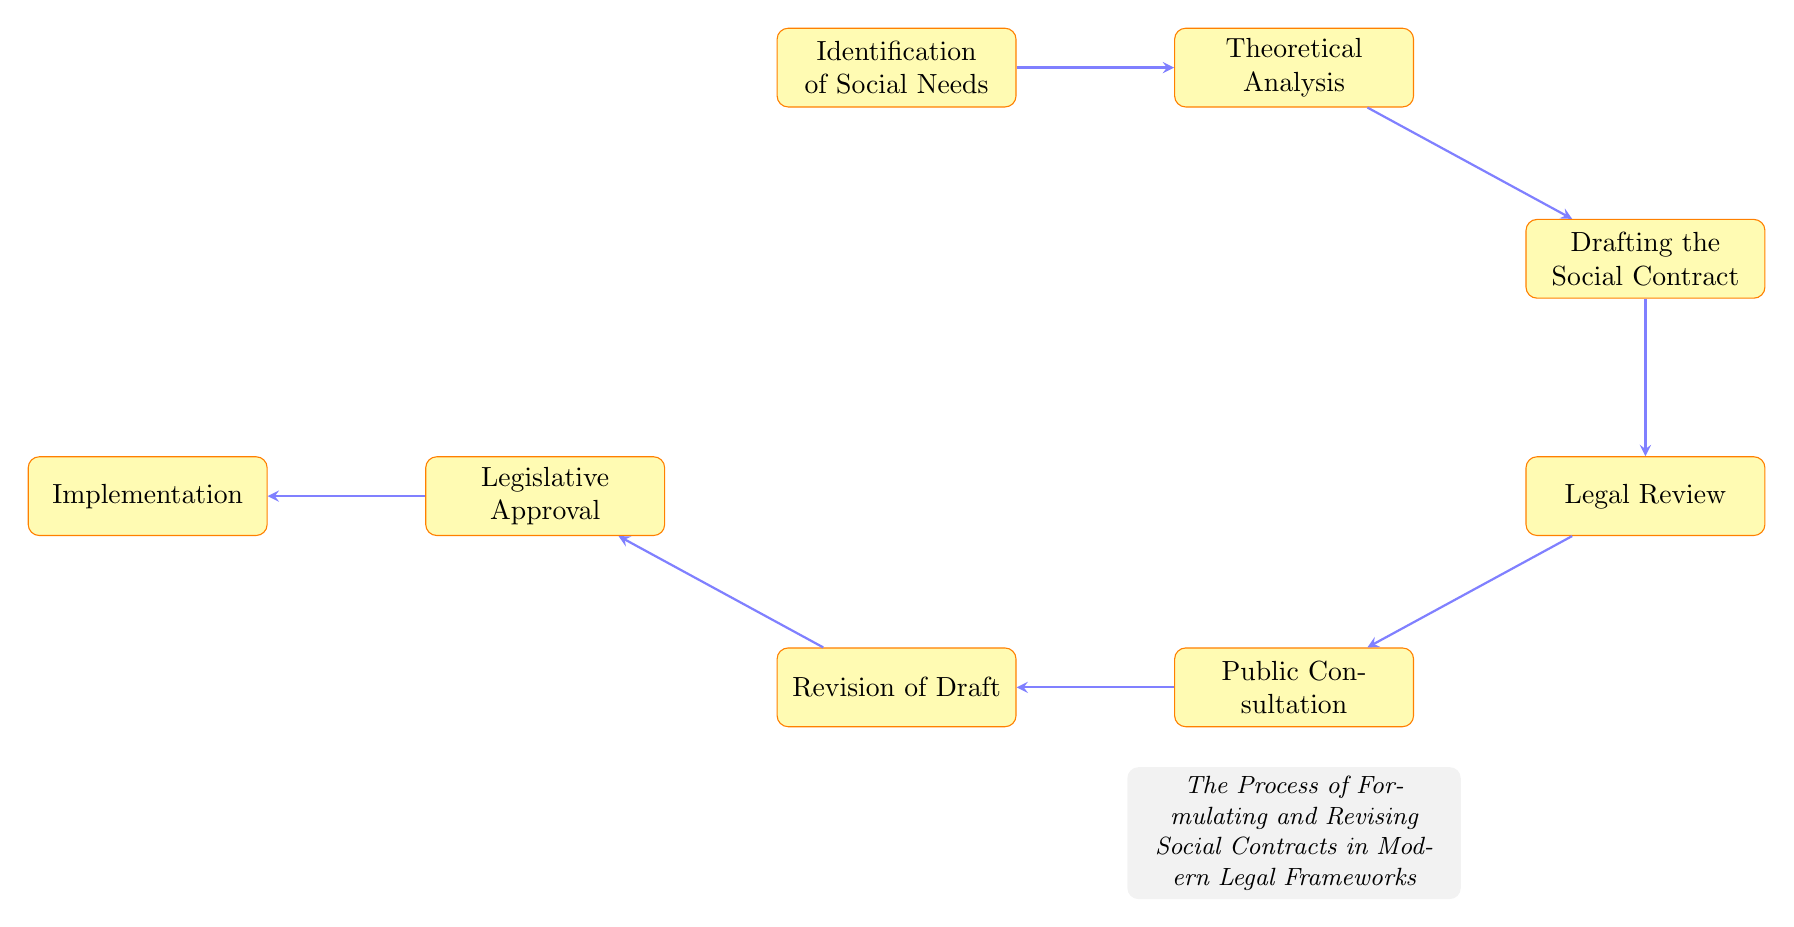What is the first step in the process? The first step in the flow chart is "Identification of Social Needs", which is indicated as the starting node.
Answer: Identification of Social Needs How many nodes are there in the diagram? By counting each unique box in the flow chart, we find there are 8 nodes in total.
Answer: 8 What follows "Public Consultation"? The node that directly follows "Public Consultation" is "Revision of Draft", shown in the sequence of the flow chart.
Answer: Revision of Draft Which node leads to "Implementation"? "Legislative Approval" is the node that leads to "Implementation", as indicated by the arrow connecting them within the flow of the diagram.
Answer: Legislative Approval What is the last node in the flow? The last node in the flow chart is "Implementation", which concludes the process depicted in the diagram.
Answer: Implementation What is the relationship between "Theoretical Analysis" and "Drafting the Social Contract"? "Drafting the Social Contract" comes directly after "Theoretical Analysis" in the process, indicating a sequential relationship.
Answer: Sequential Which node connects to the "Legal Review"? "Drafting the Social Contract" is the node that connects to "Legal Review", as it is the immediate predecessor in the flow chart.
Answer: Drafting the Social Contract What type of analysis is performed after identifying social needs? After identifying social needs, "Theoretical Analysis" is performed, which involves applying philosophical frameworks.
Answer: Theoretical Analysis How does public consultation influence the process? Public consultation impacts the process by leading to the "Revision of Draft", as feedback from this step is incorporated into the subsequent draft.
Answer: Revision of Draft 